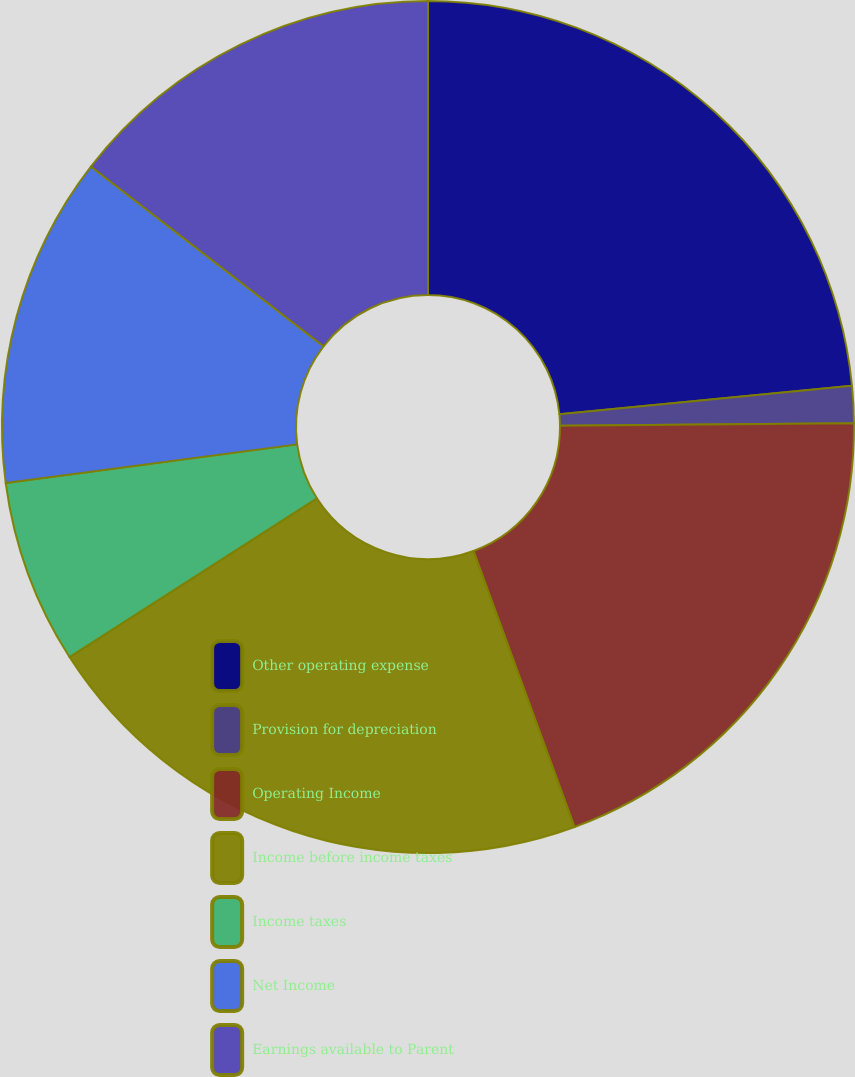<chart> <loc_0><loc_0><loc_500><loc_500><pie_chart><fcel>Other operating expense<fcel>Provision for depreciation<fcel>Operating Income<fcel>Income before income taxes<fcel>Income taxes<fcel>Net Income<fcel>Earnings available to Parent<nl><fcel>23.46%<fcel>1.4%<fcel>19.55%<fcel>21.51%<fcel>6.98%<fcel>12.57%<fcel>14.53%<nl></chart> 